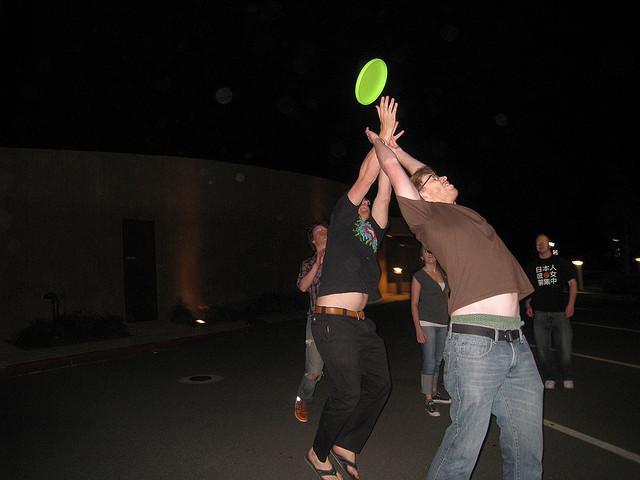How many people can be seen?
Give a very brief answer. 5. 